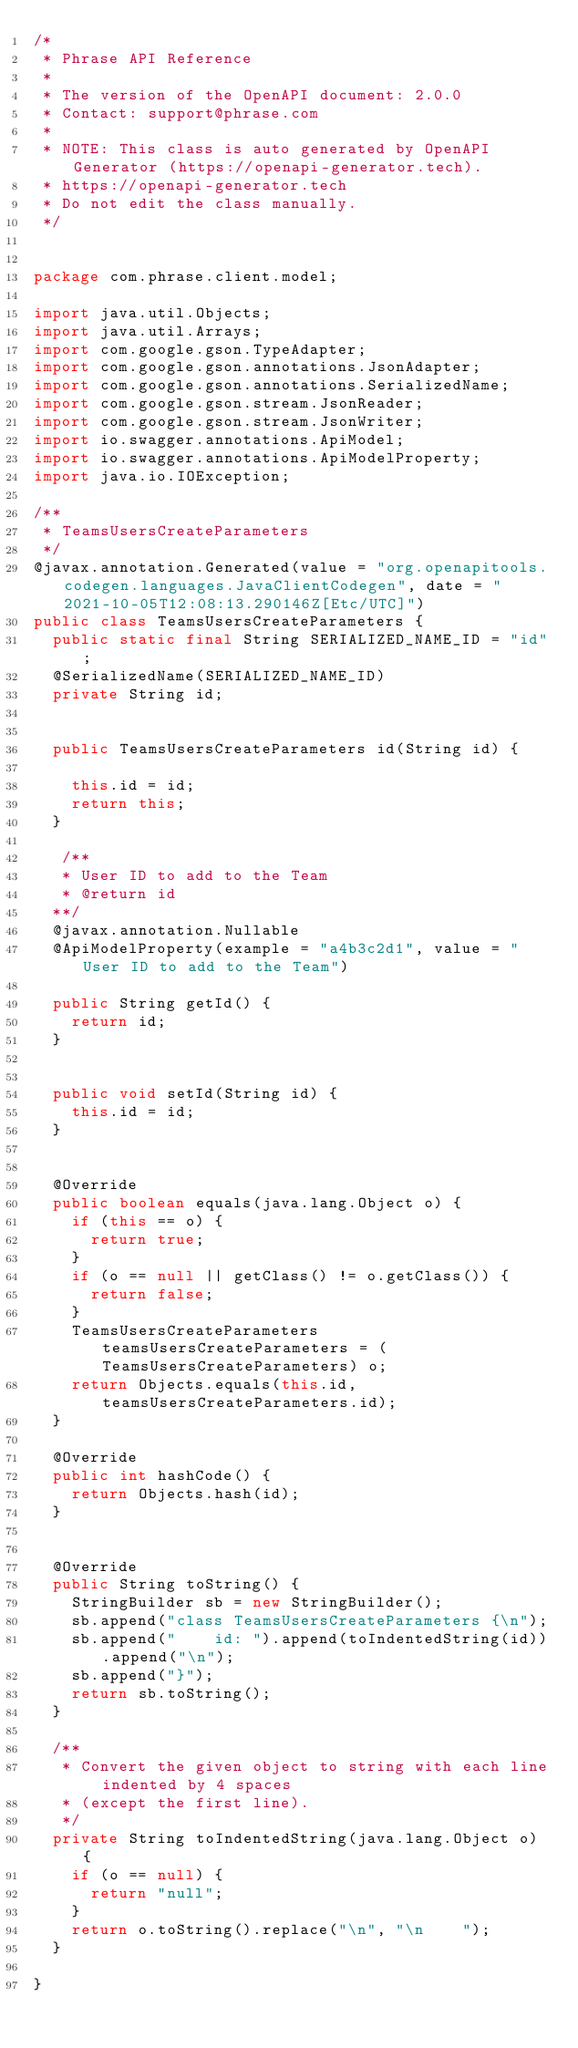Convert code to text. <code><loc_0><loc_0><loc_500><loc_500><_Java_>/*
 * Phrase API Reference
 *
 * The version of the OpenAPI document: 2.0.0
 * Contact: support@phrase.com
 *
 * NOTE: This class is auto generated by OpenAPI Generator (https://openapi-generator.tech).
 * https://openapi-generator.tech
 * Do not edit the class manually.
 */


package com.phrase.client.model;

import java.util.Objects;
import java.util.Arrays;
import com.google.gson.TypeAdapter;
import com.google.gson.annotations.JsonAdapter;
import com.google.gson.annotations.SerializedName;
import com.google.gson.stream.JsonReader;
import com.google.gson.stream.JsonWriter;
import io.swagger.annotations.ApiModel;
import io.swagger.annotations.ApiModelProperty;
import java.io.IOException;

/**
 * TeamsUsersCreateParameters
 */
@javax.annotation.Generated(value = "org.openapitools.codegen.languages.JavaClientCodegen", date = "2021-10-05T12:08:13.290146Z[Etc/UTC]")
public class TeamsUsersCreateParameters {
  public static final String SERIALIZED_NAME_ID = "id";
  @SerializedName(SERIALIZED_NAME_ID)
  private String id;


  public TeamsUsersCreateParameters id(String id) {
    
    this.id = id;
    return this;
  }

   /**
   * User ID to add to the Team
   * @return id
  **/
  @javax.annotation.Nullable
  @ApiModelProperty(example = "a4b3c2d1", value = "User ID to add to the Team")

  public String getId() {
    return id;
  }


  public void setId(String id) {
    this.id = id;
  }


  @Override
  public boolean equals(java.lang.Object o) {
    if (this == o) {
      return true;
    }
    if (o == null || getClass() != o.getClass()) {
      return false;
    }
    TeamsUsersCreateParameters teamsUsersCreateParameters = (TeamsUsersCreateParameters) o;
    return Objects.equals(this.id, teamsUsersCreateParameters.id);
  }

  @Override
  public int hashCode() {
    return Objects.hash(id);
  }


  @Override
  public String toString() {
    StringBuilder sb = new StringBuilder();
    sb.append("class TeamsUsersCreateParameters {\n");
    sb.append("    id: ").append(toIndentedString(id)).append("\n");
    sb.append("}");
    return sb.toString();
  }

  /**
   * Convert the given object to string with each line indented by 4 spaces
   * (except the first line).
   */
  private String toIndentedString(java.lang.Object o) {
    if (o == null) {
      return "null";
    }
    return o.toString().replace("\n", "\n    ");
  }

}

</code> 